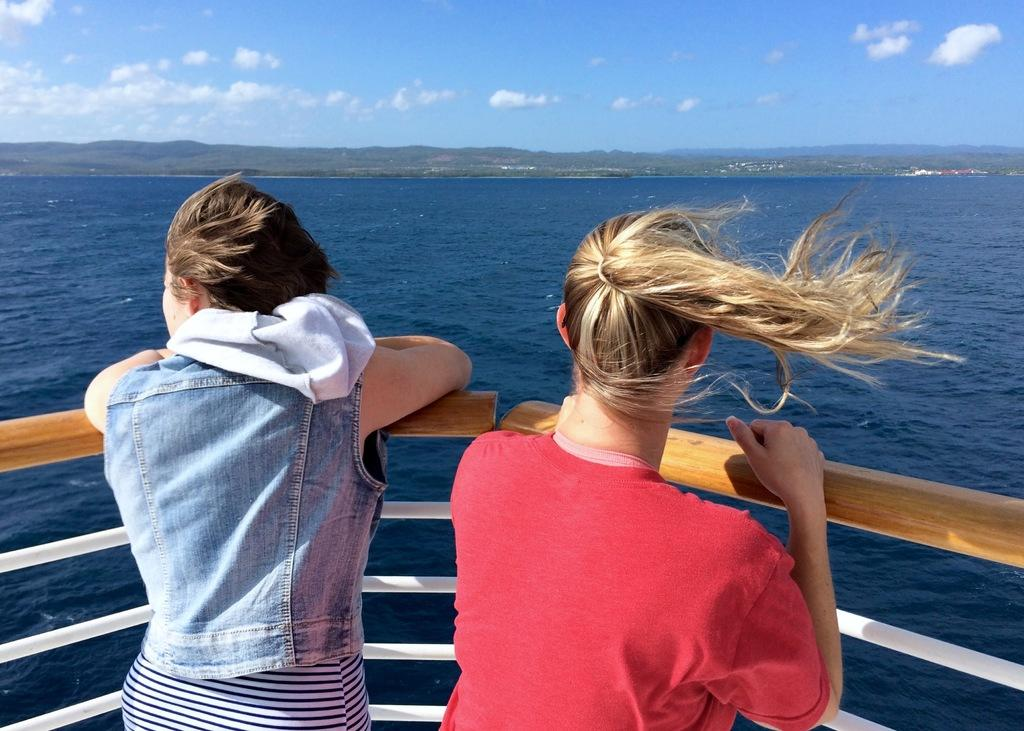How many people can be seen at the front part of the ship in the image? There are two persons standing at the front part of the ship in the image. What is the ship's location in relation to its surroundings? The ship is in the water. What type of landscape can be seen in the image? There are mountains visible in the image. What is the condition of the sky in the image? There are clouds in the sky. What type of pest can be seen crawling on the ship in the image? There is no pest visible on the ship in the image. Is the image a work of fiction or non-fiction? The image itself is neither fiction nor non-fiction; it is a photograph. However, the context in which it is used could be considered fiction or non-fiction. How do the two persons standing at the front part of the ship show respect to the mountains in the image? The image does not provide any information about the two persons showing respect to the mountains. 